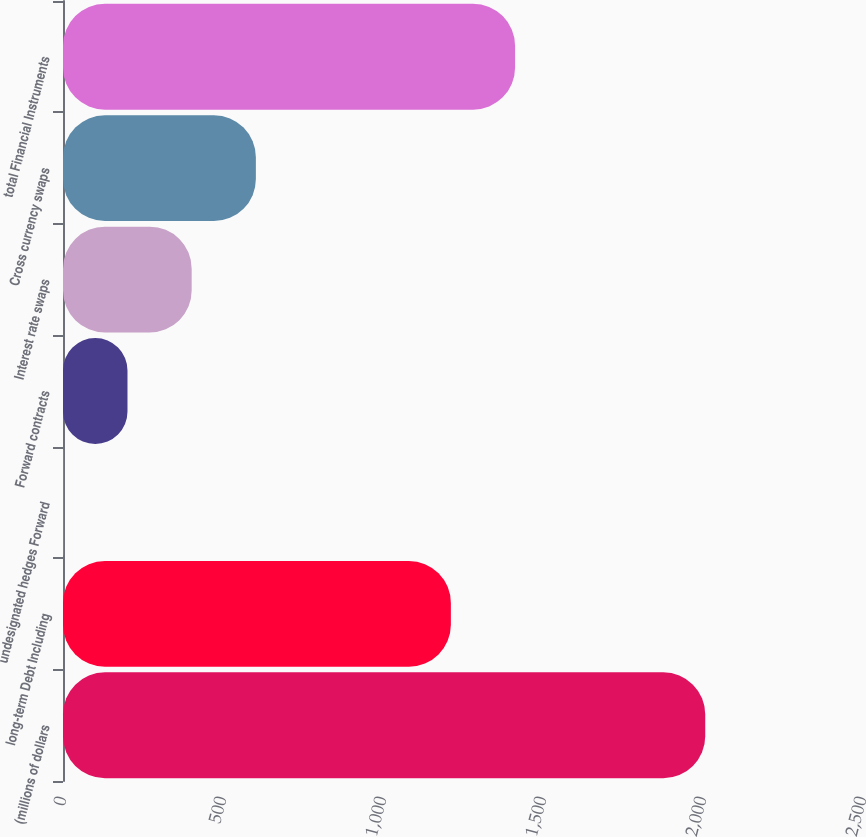Convert chart to OTSL. <chart><loc_0><loc_0><loc_500><loc_500><bar_chart><fcel>(millions of dollars<fcel>long-term Debt Including<fcel>undesignated hedges Forward<fcel>Forward contracts<fcel>Interest rate swaps<fcel>Cross currency swaps<fcel>total Financial Instruments<nl><fcel>2007<fcel>1212.1<fcel>0.9<fcel>201.51<fcel>402.12<fcel>602.73<fcel>1412.71<nl></chart> 